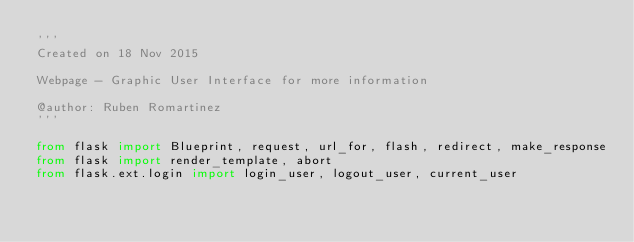Convert code to text. <code><loc_0><loc_0><loc_500><loc_500><_Python_>'''
Created on 18 Nov 2015

Webpage - Graphic User Interface for more information

@author: Ruben Romartinez
'''

from flask import Blueprint, request, url_for, flash, redirect, make_response
from flask import render_template, abort
from flask.ext.login import login_user, logout_user, current_user
</code> 